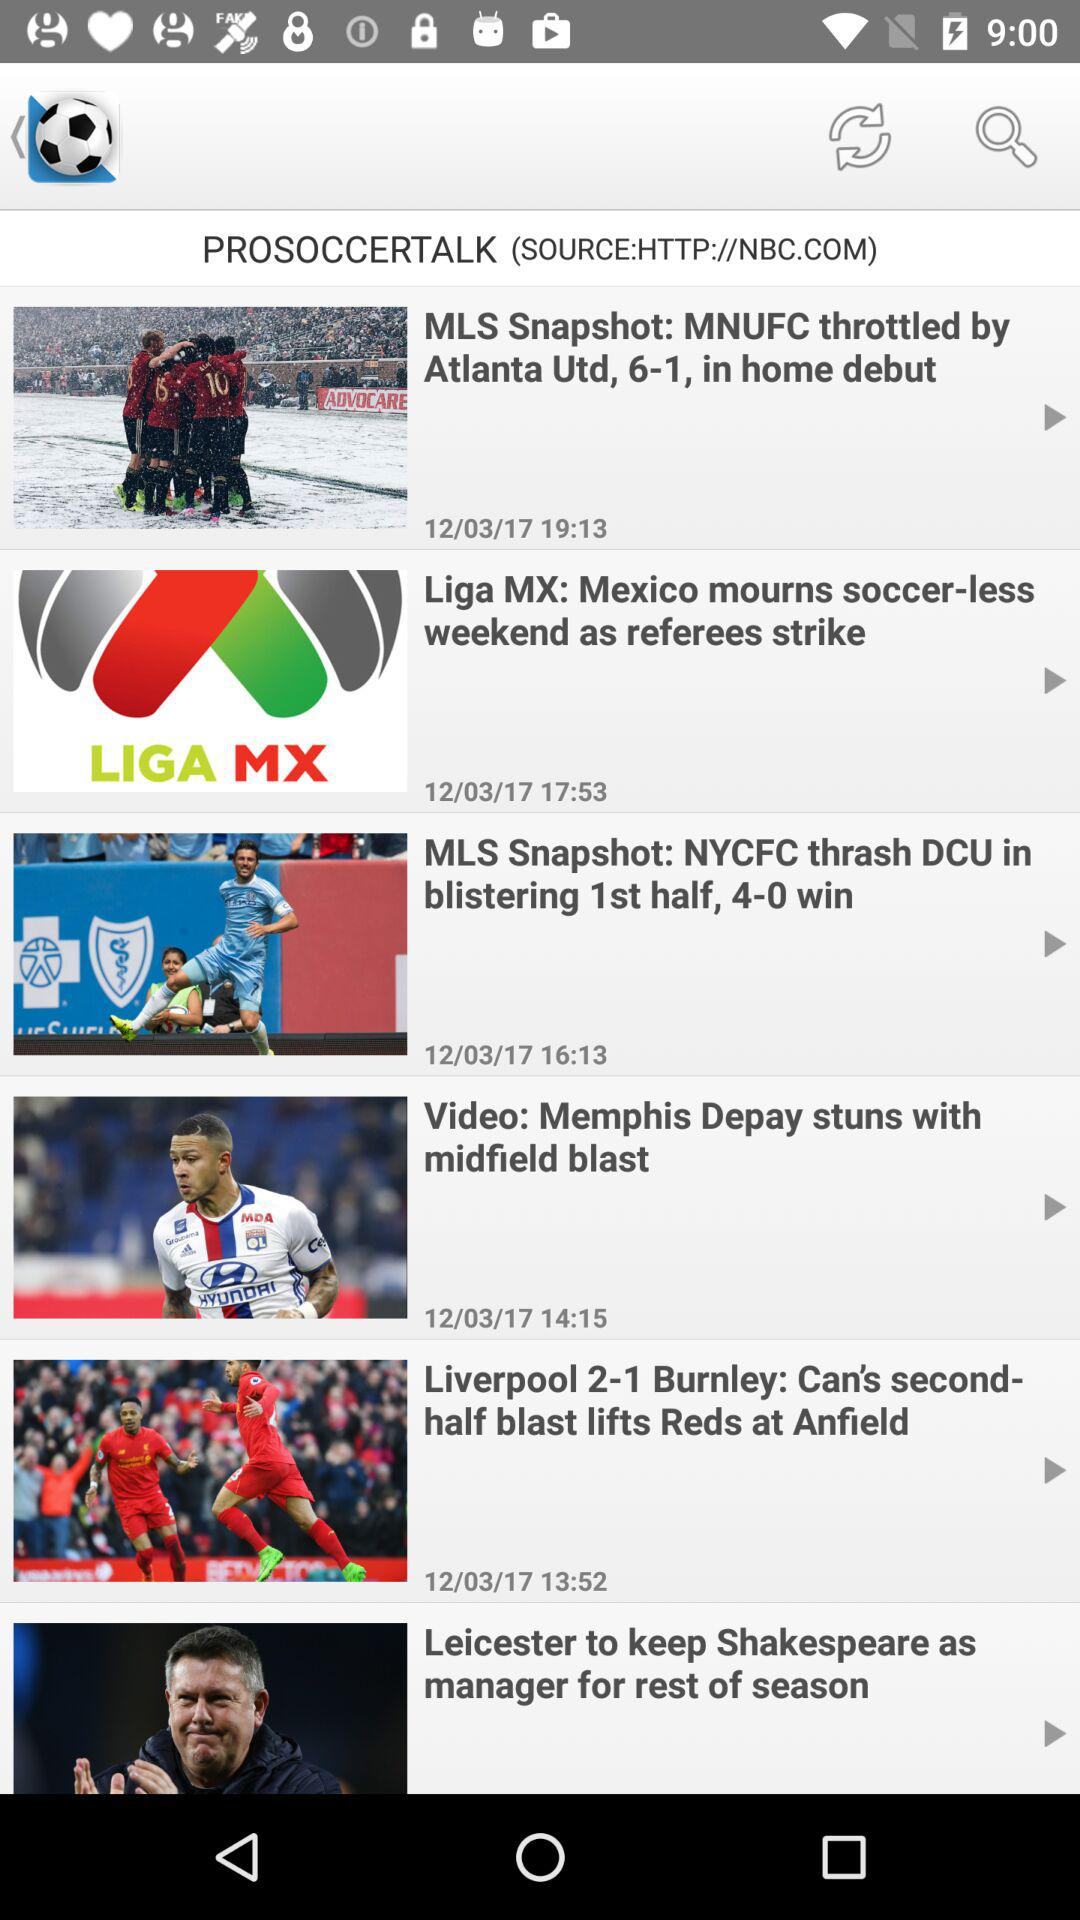What headline was published on 12/03/17 at 17:53? The headline is "Liga MX: Mexico mourns soccer-less weekend as referees strike". 